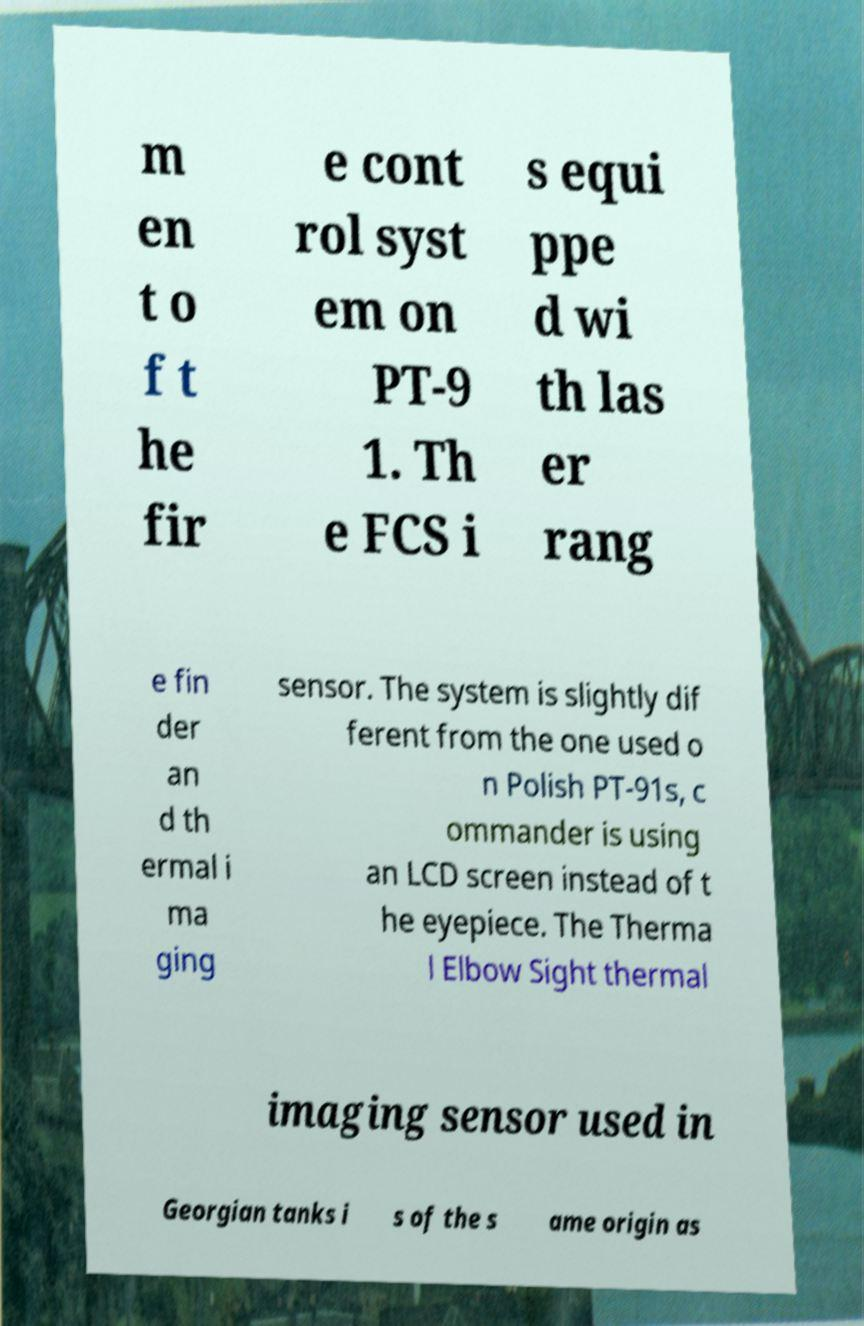Please read and relay the text visible in this image. What does it say? m en t o f t he fir e cont rol syst em on PT-9 1. Th e FCS i s equi ppe d wi th las er rang e fin der an d th ermal i ma ging sensor. The system is slightly dif ferent from the one used o n Polish PT-91s, c ommander is using an LCD screen instead of t he eyepiece. The Therma l Elbow Sight thermal imaging sensor used in Georgian tanks i s of the s ame origin as 